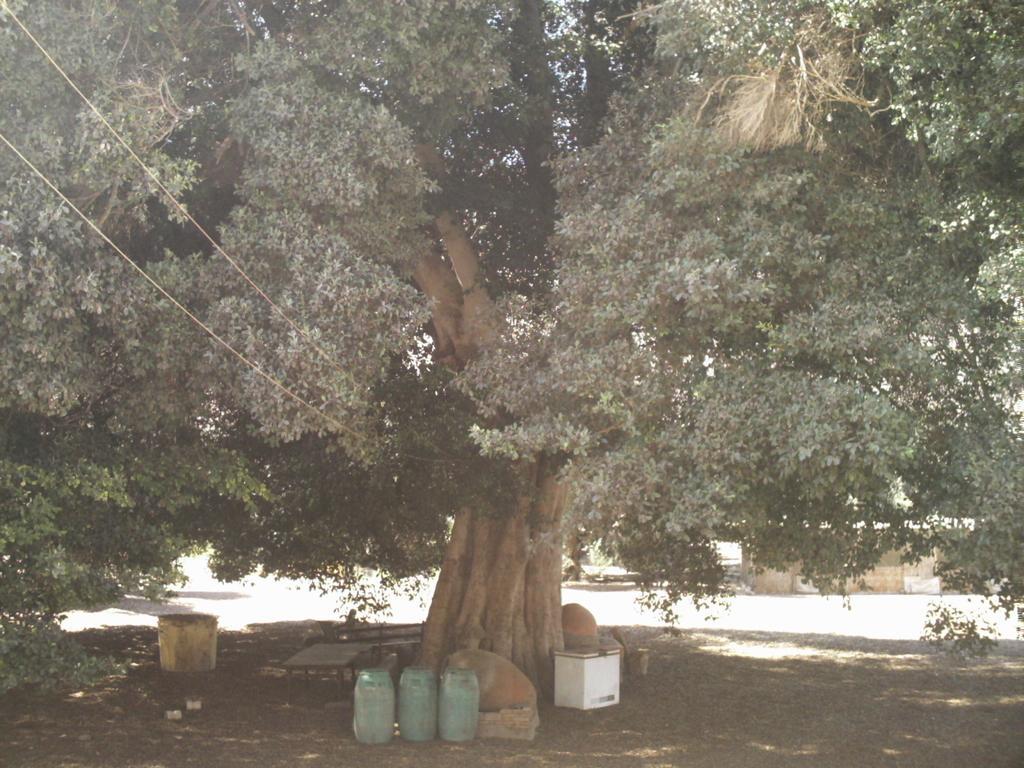How would you summarize this image in a sentence or two? In this image there is a tree on the ground. In front of the tree there are boxes, barrels and benches. Behind the tree there is a house. 